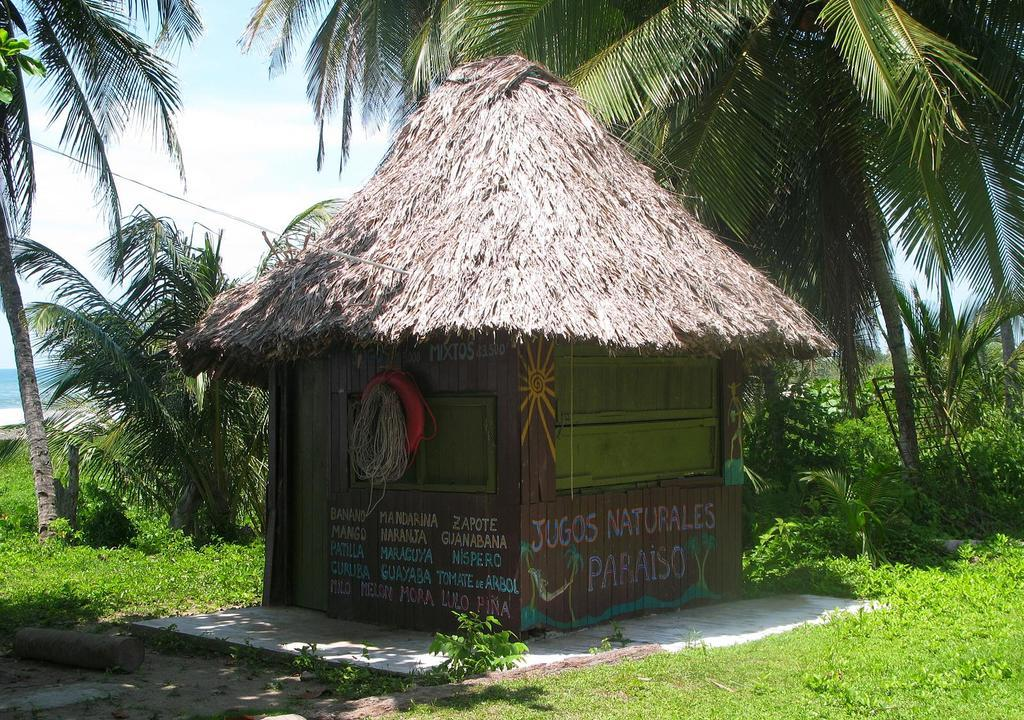What type of vegetation can be seen in the image? There are trees, plants, and grass visible in the image. What type of structure is present in the image? There is a house in the image. What objects can be seen in the image that are not related to vegetation or the house? There is a rope and a tube visible in the image. What part of the natural environment is visible in the image? The sky is visible in the image, along with clouds. What type of learning is taking place in the image? There is no indication of any learning or educational activity taking place in the image. What color is the roof of the house in the image? There is no roof visible in the image, only the house itself. 